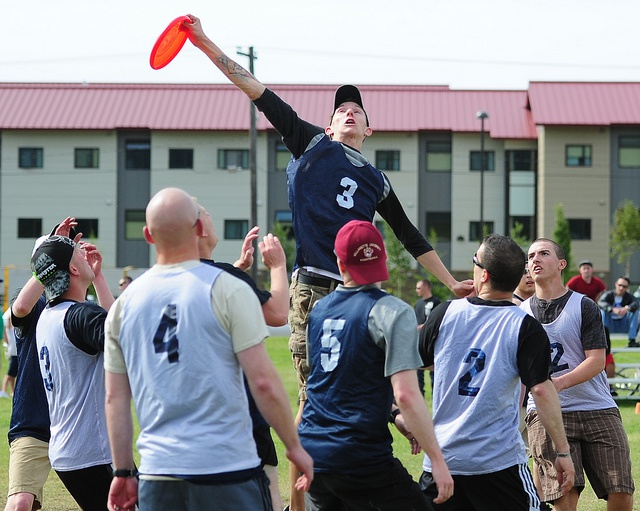Describe the objects in this image and their specific colors. I can see people in white, darkgray, black, and lightgray tones, people in white, black, gray, and darkgray tones, people in white, black, navy, darkgray, and gray tones, people in white, black, navy, darkgray, and gray tones, and people in white, black, gray, and darkgray tones in this image. 